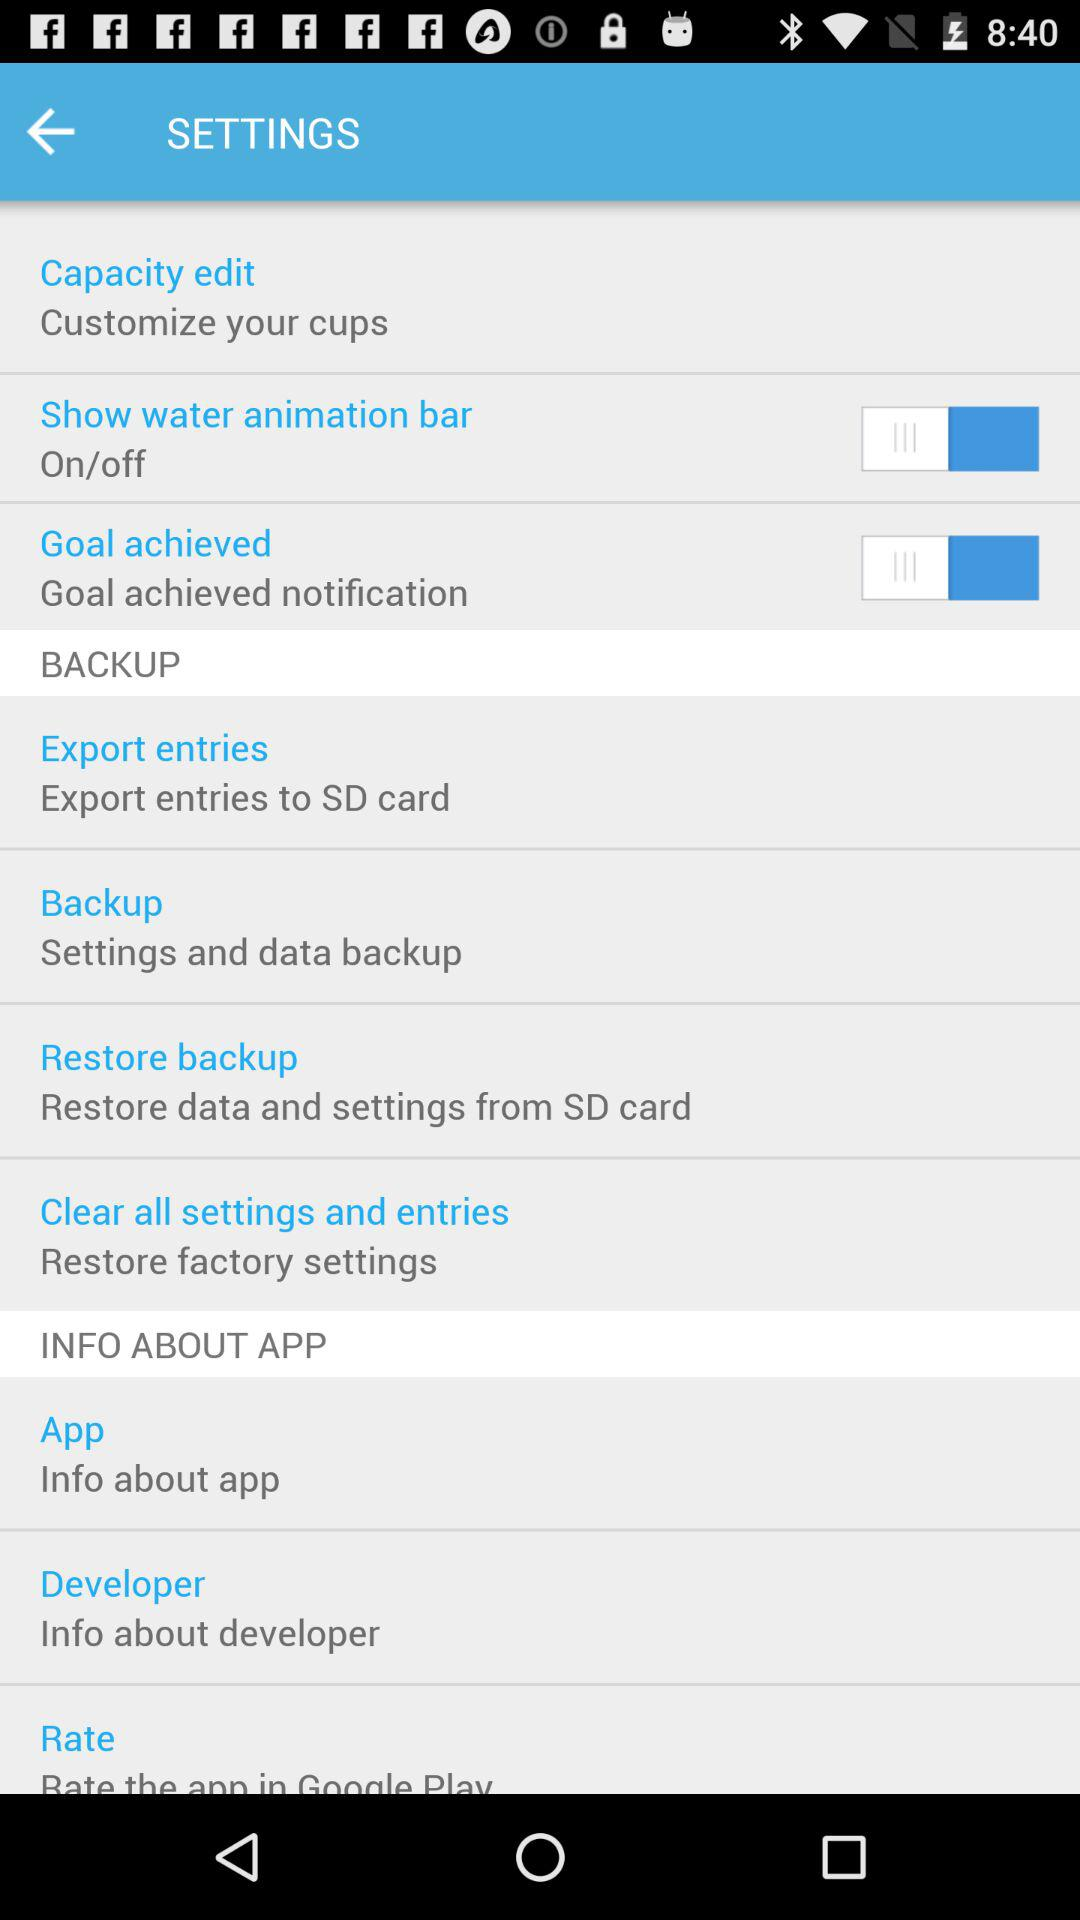What is the status of the "Goal achieved" notification? The status is "off". 